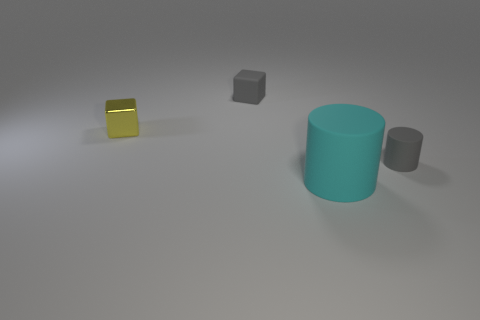Is there anything else that has the same size as the cyan matte thing?
Your answer should be very brief. No. There is a gray thing in front of the matte thing that is behind the small gray matte thing that is to the right of the rubber cube; what is it made of?
Ensure brevity in your answer.  Rubber. There is a large cyan thing; is its shape the same as the gray matte object that is in front of the yellow block?
Your response must be concise. Yes. How many gray things are the same shape as the small yellow object?
Your answer should be very brief. 1. There is a small yellow shiny object; what shape is it?
Your answer should be very brief. Cube. How big is the cyan thing that is in front of the tiny rubber thing that is behind the gray matte cylinder?
Your answer should be compact. Large. How many objects are yellow metal objects or small cyan metal cylinders?
Ensure brevity in your answer.  1. Is there a large brown cylinder that has the same material as the big cyan object?
Ensure brevity in your answer.  No. There is a thing behind the tiny yellow cube; are there any cyan matte objects that are on the left side of it?
Your answer should be very brief. No. Does the object that is in front of the gray cylinder have the same size as the gray matte block?
Ensure brevity in your answer.  No. 